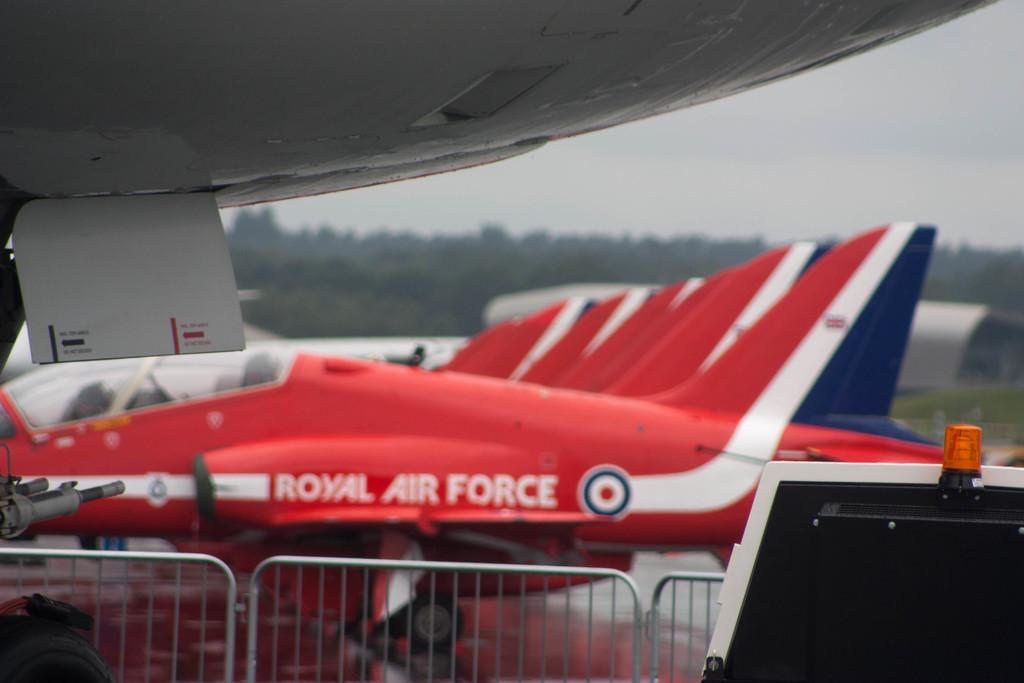What is the name of that plane?
Your answer should be compact. Royal air force. 